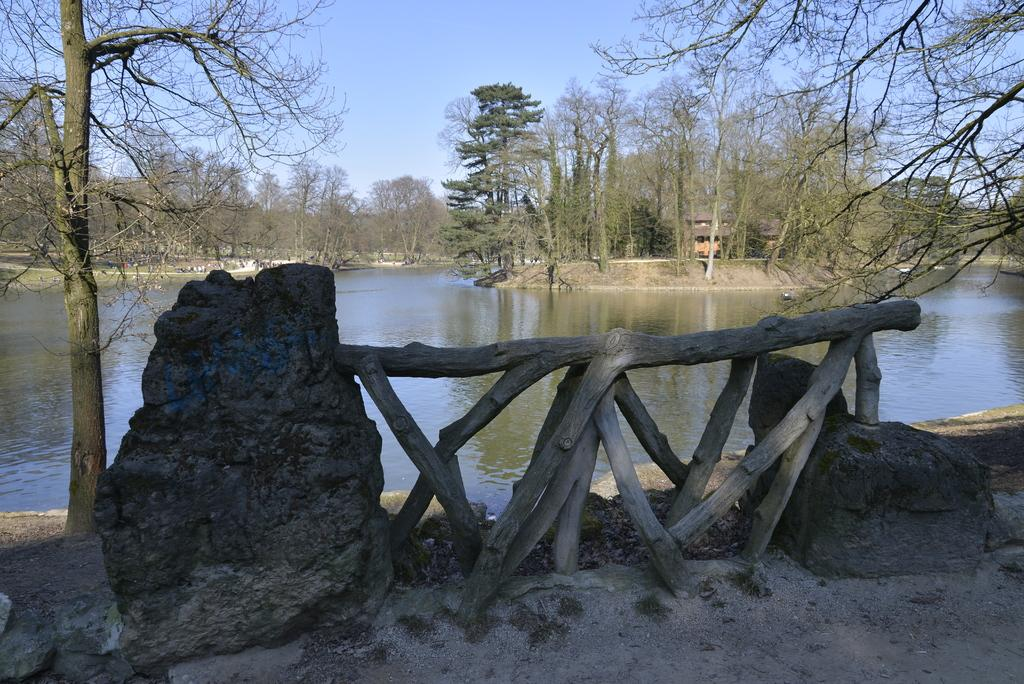What type of natural materials can be seen in the image? There are stones and wooden logs in the image. What is visible in the background of the image? There is water, trees, and a clear sky visible in the background of the image. How much does the beggar weigh in the image? There is no beggar present in the image, so it is not possible to determine their weight. 